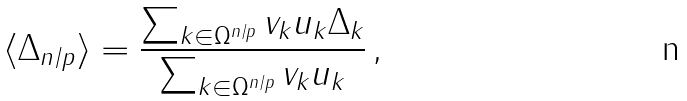<formula> <loc_0><loc_0><loc_500><loc_500>\langle \Delta _ { n / p } \rangle = \frac { \sum _ { k \in \Omega ^ { n / p } } v _ { k } u _ { k } \Delta _ { k } } { \sum _ { k \in \Omega ^ { n / p } } v _ { k } u _ { k } } \, ,</formula> 